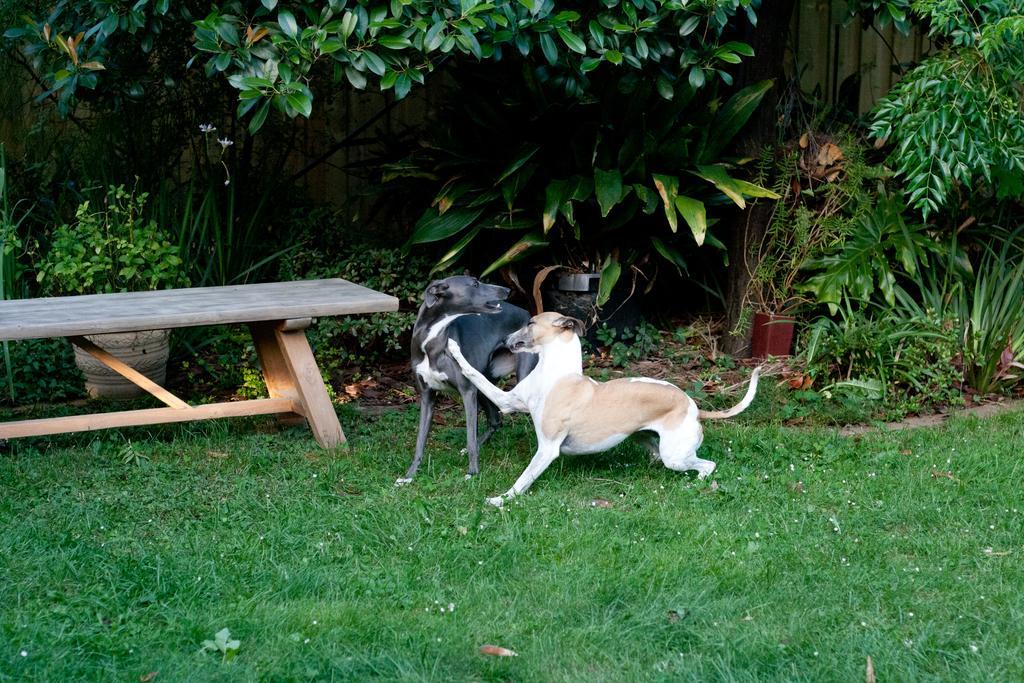Please provide a concise description of this image. There are two dogs on a greenery ground and there is a bench and trees in the background. 